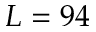Convert formula to latex. <formula><loc_0><loc_0><loc_500><loc_500>L = 9 4</formula> 